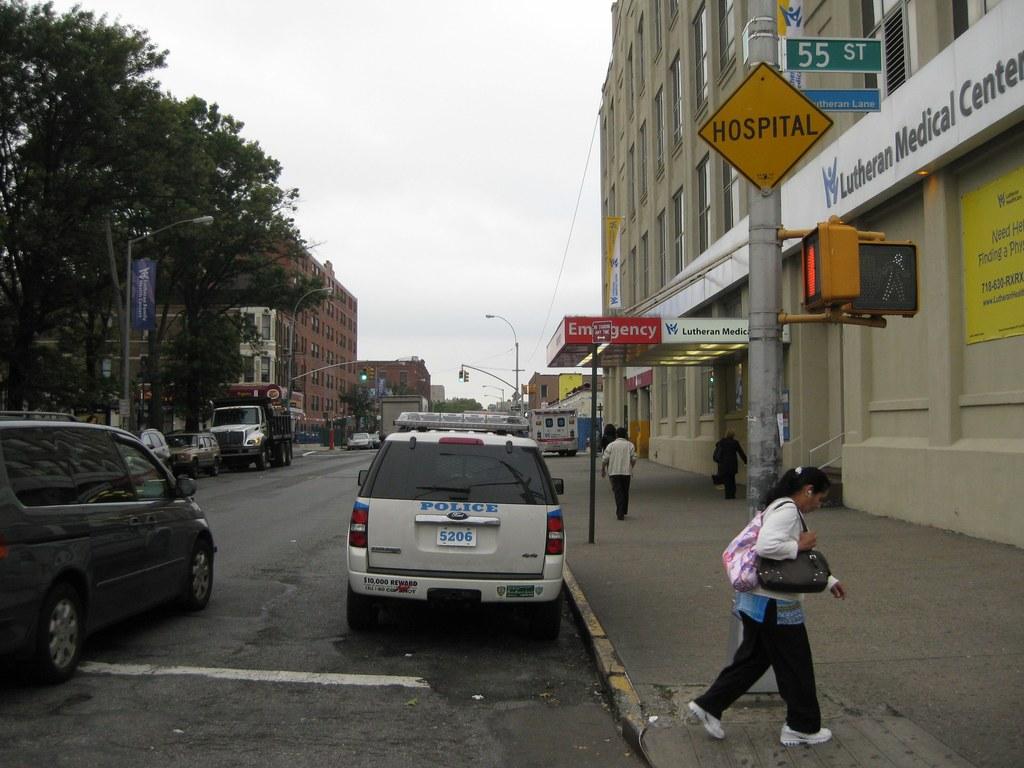Is there a hospital near by?
Offer a terse response. Yes. 